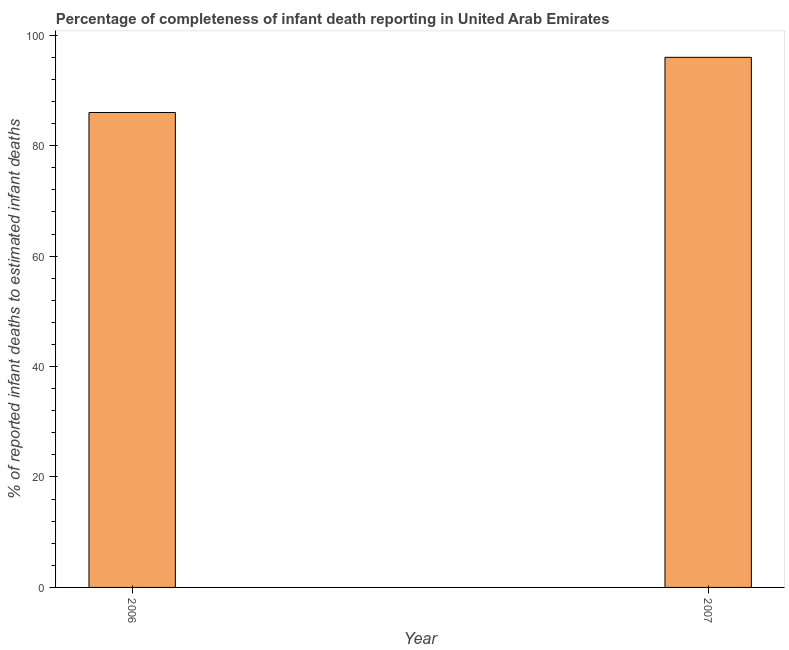Does the graph contain any zero values?
Your response must be concise. No. What is the title of the graph?
Offer a very short reply. Percentage of completeness of infant death reporting in United Arab Emirates. What is the label or title of the X-axis?
Make the answer very short. Year. What is the label or title of the Y-axis?
Your answer should be compact. % of reported infant deaths to estimated infant deaths. What is the completeness of infant death reporting in 2007?
Your answer should be compact. 96. Across all years, what is the maximum completeness of infant death reporting?
Provide a short and direct response. 96. Across all years, what is the minimum completeness of infant death reporting?
Offer a very short reply. 86.01. What is the sum of the completeness of infant death reporting?
Ensure brevity in your answer.  182.01. What is the difference between the completeness of infant death reporting in 2006 and 2007?
Keep it short and to the point. -9.99. What is the average completeness of infant death reporting per year?
Keep it short and to the point. 91.01. What is the median completeness of infant death reporting?
Provide a succinct answer. 91.01. In how many years, is the completeness of infant death reporting greater than 4 %?
Your response must be concise. 2. What is the ratio of the completeness of infant death reporting in 2006 to that in 2007?
Provide a short and direct response. 0.9. Is the completeness of infant death reporting in 2006 less than that in 2007?
Your answer should be compact. Yes. How many years are there in the graph?
Make the answer very short. 2. What is the % of reported infant deaths to estimated infant deaths of 2006?
Keep it short and to the point. 86.01. What is the % of reported infant deaths to estimated infant deaths in 2007?
Ensure brevity in your answer.  96. What is the difference between the % of reported infant deaths to estimated infant deaths in 2006 and 2007?
Your answer should be compact. -9.99. What is the ratio of the % of reported infant deaths to estimated infant deaths in 2006 to that in 2007?
Make the answer very short. 0.9. 